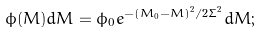Convert formula to latex. <formula><loc_0><loc_0><loc_500><loc_500>\phi ( M ) d M = \phi _ { 0 } e ^ { - ( M _ { 0 } - M ) ^ { 2 } / 2 \Sigma ^ { 2 } } d M ;</formula> 